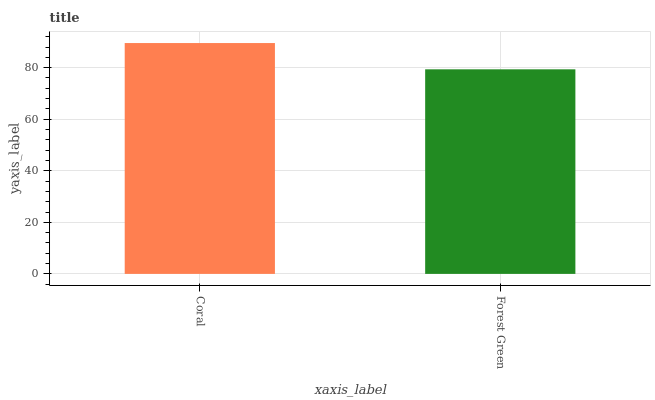Is Forest Green the minimum?
Answer yes or no. Yes. Is Coral the maximum?
Answer yes or no. Yes. Is Forest Green the maximum?
Answer yes or no. No. Is Coral greater than Forest Green?
Answer yes or no. Yes. Is Forest Green less than Coral?
Answer yes or no. Yes. Is Forest Green greater than Coral?
Answer yes or no. No. Is Coral less than Forest Green?
Answer yes or no. No. Is Coral the high median?
Answer yes or no. Yes. Is Forest Green the low median?
Answer yes or no. Yes. Is Forest Green the high median?
Answer yes or no. No. Is Coral the low median?
Answer yes or no. No. 